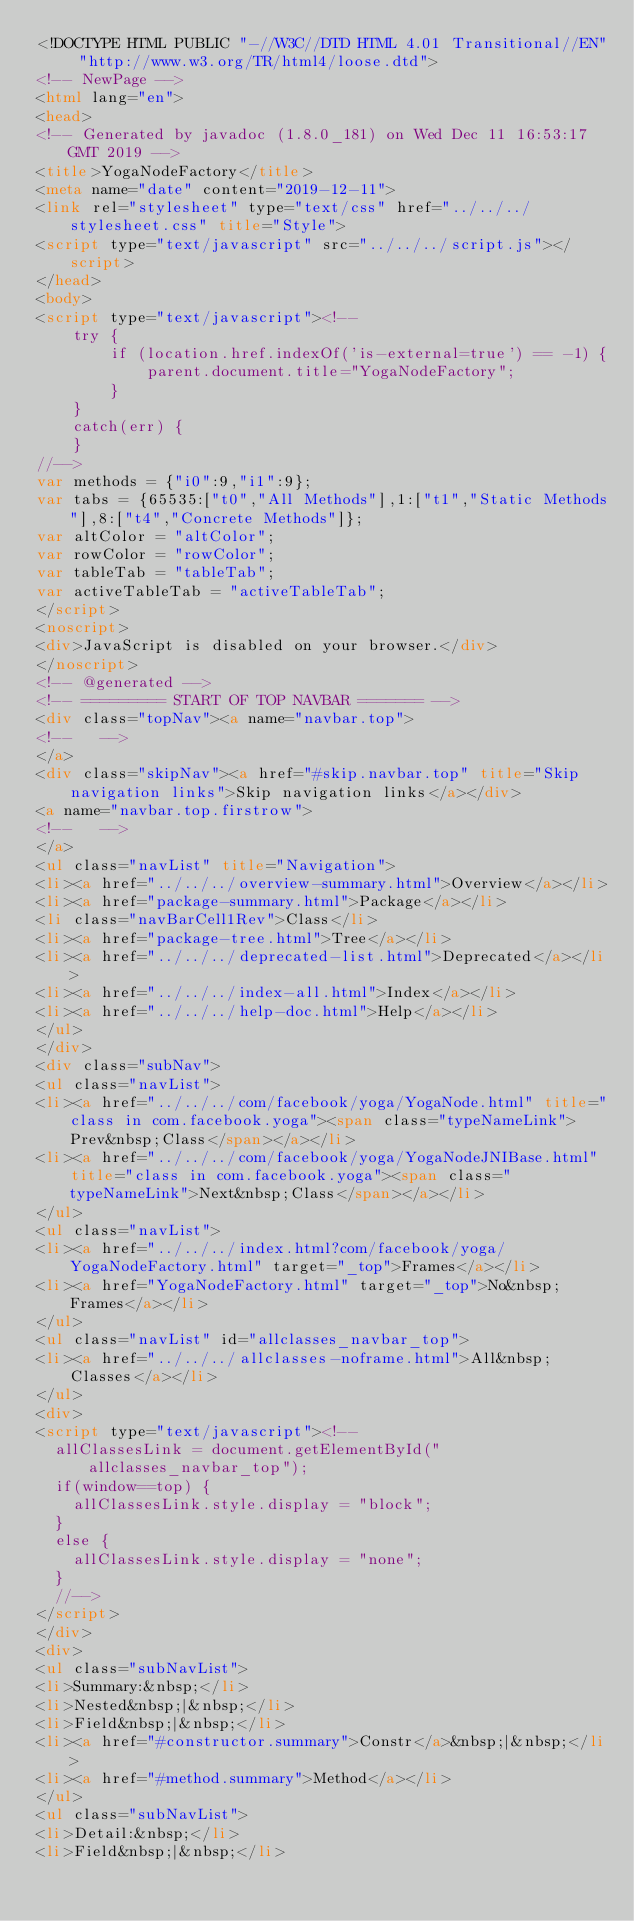Convert code to text. <code><loc_0><loc_0><loc_500><loc_500><_HTML_><!DOCTYPE HTML PUBLIC "-//W3C//DTD HTML 4.01 Transitional//EN" "http://www.w3.org/TR/html4/loose.dtd">
<!-- NewPage -->
<html lang="en">
<head>
<!-- Generated by javadoc (1.8.0_181) on Wed Dec 11 16:53:17 GMT 2019 -->
<title>YogaNodeFactory</title>
<meta name="date" content="2019-12-11">
<link rel="stylesheet" type="text/css" href="../../../stylesheet.css" title="Style">
<script type="text/javascript" src="../../../script.js"></script>
</head>
<body>
<script type="text/javascript"><!--
    try {
        if (location.href.indexOf('is-external=true') == -1) {
            parent.document.title="YogaNodeFactory";
        }
    }
    catch(err) {
    }
//-->
var methods = {"i0":9,"i1":9};
var tabs = {65535:["t0","All Methods"],1:["t1","Static Methods"],8:["t4","Concrete Methods"]};
var altColor = "altColor";
var rowColor = "rowColor";
var tableTab = "tableTab";
var activeTableTab = "activeTableTab";
</script>
<noscript>
<div>JavaScript is disabled on your browser.</div>
</noscript>
<!-- @generated -->
<!-- ========= START OF TOP NAVBAR ======= -->
<div class="topNav"><a name="navbar.top">
<!--   -->
</a>
<div class="skipNav"><a href="#skip.navbar.top" title="Skip navigation links">Skip navigation links</a></div>
<a name="navbar.top.firstrow">
<!--   -->
</a>
<ul class="navList" title="Navigation">
<li><a href="../../../overview-summary.html">Overview</a></li>
<li><a href="package-summary.html">Package</a></li>
<li class="navBarCell1Rev">Class</li>
<li><a href="package-tree.html">Tree</a></li>
<li><a href="../../../deprecated-list.html">Deprecated</a></li>
<li><a href="../../../index-all.html">Index</a></li>
<li><a href="../../../help-doc.html">Help</a></li>
</ul>
</div>
<div class="subNav">
<ul class="navList">
<li><a href="../../../com/facebook/yoga/YogaNode.html" title="class in com.facebook.yoga"><span class="typeNameLink">Prev&nbsp;Class</span></a></li>
<li><a href="../../../com/facebook/yoga/YogaNodeJNIBase.html" title="class in com.facebook.yoga"><span class="typeNameLink">Next&nbsp;Class</span></a></li>
</ul>
<ul class="navList">
<li><a href="../../../index.html?com/facebook/yoga/YogaNodeFactory.html" target="_top">Frames</a></li>
<li><a href="YogaNodeFactory.html" target="_top">No&nbsp;Frames</a></li>
</ul>
<ul class="navList" id="allclasses_navbar_top">
<li><a href="../../../allclasses-noframe.html">All&nbsp;Classes</a></li>
</ul>
<div>
<script type="text/javascript"><!--
  allClassesLink = document.getElementById("allclasses_navbar_top");
  if(window==top) {
    allClassesLink.style.display = "block";
  }
  else {
    allClassesLink.style.display = "none";
  }
  //-->
</script>
</div>
<div>
<ul class="subNavList">
<li>Summary:&nbsp;</li>
<li>Nested&nbsp;|&nbsp;</li>
<li>Field&nbsp;|&nbsp;</li>
<li><a href="#constructor.summary">Constr</a>&nbsp;|&nbsp;</li>
<li><a href="#method.summary">Method</a></li>
</ul>
<ul class="subNavList">
<li>Detail:&nbsp;</li>
<li>Field&nbsp;|&nbsp;</li></code> 